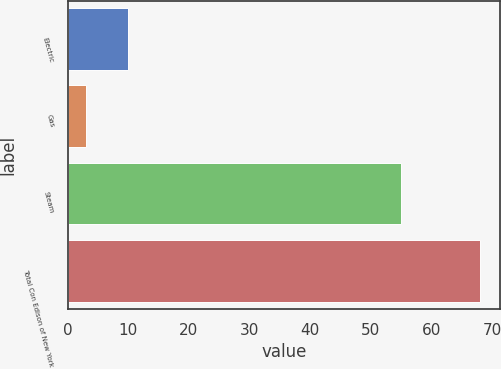<chart> <loc_0><loc_0><loc_500><loc_500><bar_chart><fcel>Electric<fcel>Gas<fcel>Steam<fcel>Total Con Edison of New York<nl><fcel>10<fcel>3<fcel>55<fcel>68<nl></chart> 